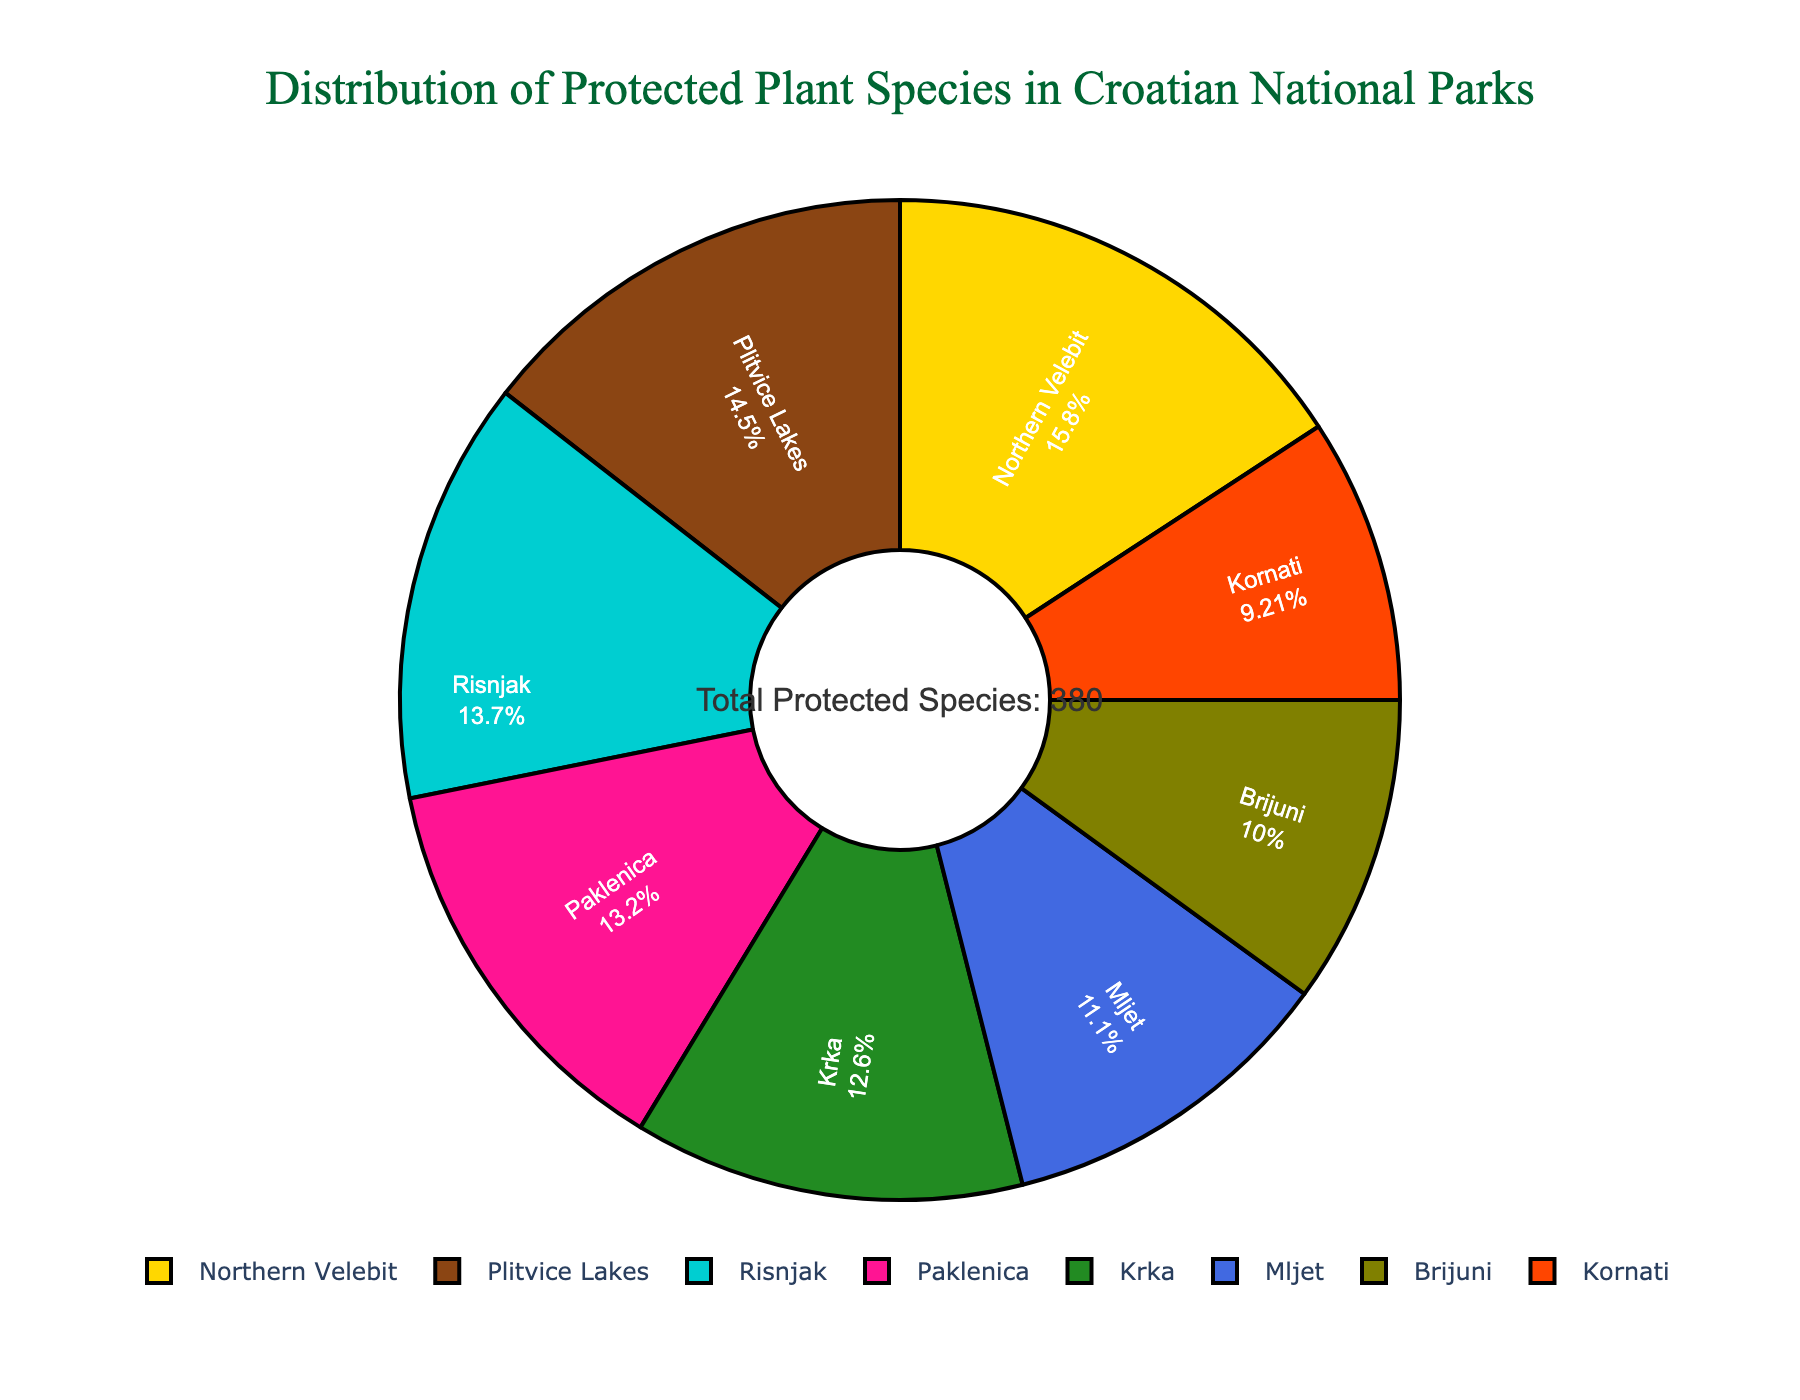What is the national park with the highest number of protected plant species? By looking at the pie chart and observing the labels and percentages, we see that Northern Velebit has the highest number of protected plant species since it occupies the largest segment.
Answer: Northern Velebit Which national park has fewer protected plant species: Kornati or Mljet? Comparing the segments of the pie chart for Kornati and Mljet, Kornati has a smaller slice indicating fewer protected plant species.
Answer: Kornati What percentage of the total protected plant species is found in Paklenica National Park? By referring to Paklenica's segment in the pie chart, the chart provides both the label and percentage, which is essential for answering this.
Answer: 16.3% Add up the number of protected plant species in Plitvice Lakes and Krka National Parks. Plitvice Lakes has 55 protected plant species and Krka has 48. Summing these gives us 55 + 48 = 103.
Answer: 103 What is the color representing Mljet National Park? Mljet is represented by a slice colored pink.
Answer: Pink Rank the national parks from the highest to the lowest number of protected plant species. By looking at the sizes of the slices and labels on the pie chart, we can rank them: Northern Velebit, Plitvice Lakes, Risnjak, Paklenica, Krka, Mljet, Brijuni, Kornati.
Answer: Northern Velebit, Plitvice Lakes, Risnjak, Paklenica, Krka, Mljet, Brijuni, Kornati Which two national parks combined have the same number of protected plant species as Northern Velebit? Northern Velebit has 60 protected plant species. Looking at pairs, Plitvice Lakes (55) and Krka (48), we see that their sum is 55 + 48 = 103, which is not equal to 60. Checking Risnjak (52) and Brijuni (38), their sum is 52 + 38 = 90. Finally, Kornati (35) and Paklenica (50) add up to 35 + 50 = 85. The correct pairs are Paklenica (50) and Mljet (10).
Answer: Paklenica and Mljet 